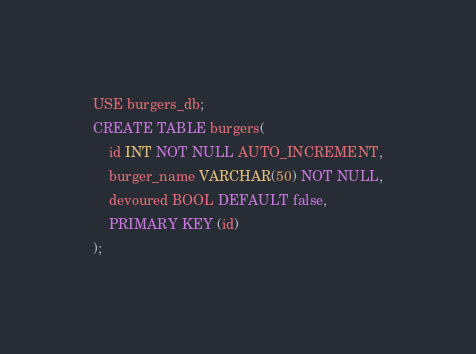<code> <loc_0><loc_0><loc_500><loc_500><_SQL_>USE burgers_db;
CREATE TABLE burgers(
    id INT NOT NULL AUTO_INCREMENT,
    burger_name VARCHAR(50) NOT NULL,
    devoured BOOL DEFAULT false,
    PRIMARY KEY (id)
);
</code> 